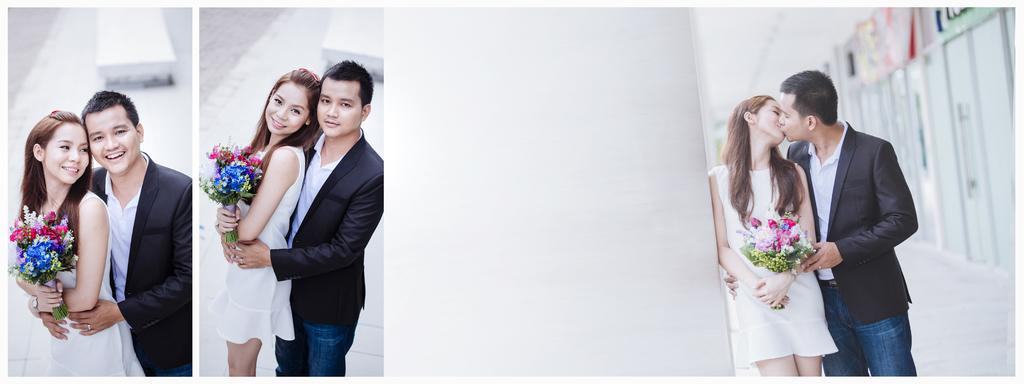What type of artwork is the image? The image is a collage. What is the primary setting in the image? There is a floor in the image. Can you describe any objects present in the image? Yes, there is an object in the image. Are there any people in the image? Yes, there are people in the image. What is one person doing in the image? There is a person holding a flower vase in the image. What architectural feature can be seen in the image? There are doors in the image. How many hoses are visible in the image? There are no hoses present in the image. What type of pies can be seen on the table in the image? There are no pies visible in the image. 